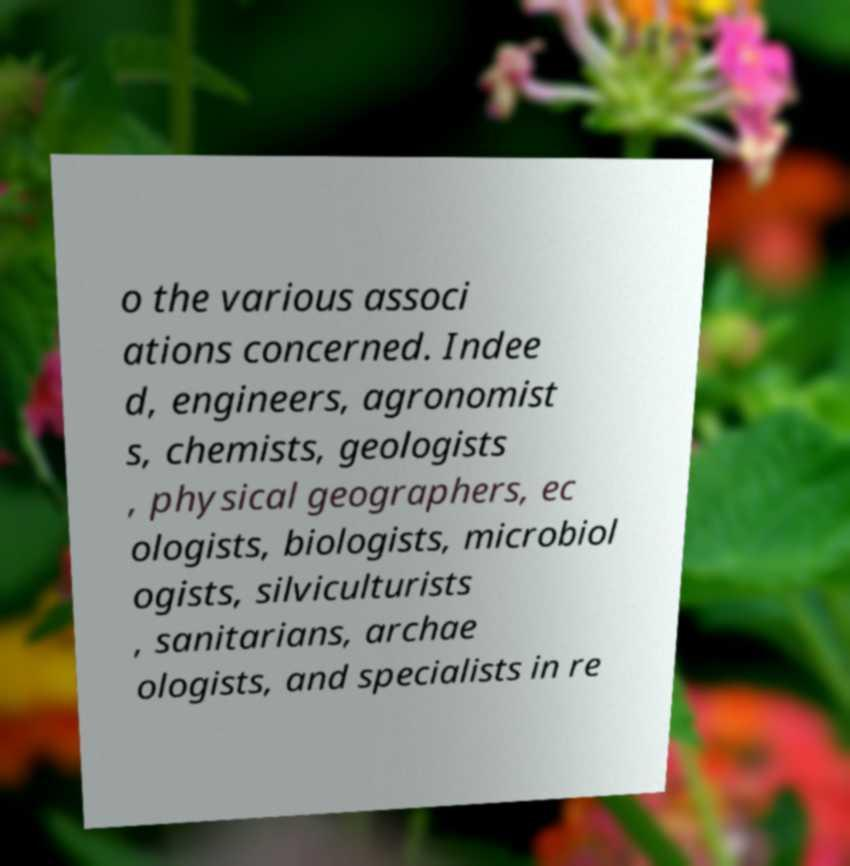There's text embedded in this image that I need extracted. Can you transcribe it verbatim? o the various associ ations concerned. Indee d, engineers, agronomist s, chemists, geologists , physical geographers, ec ologists, biologists, microbiol ogists, silviculturists , sanitarians, archae ologists, and specialists in re 